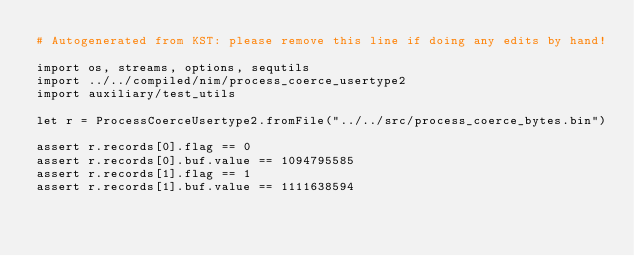<code> <loc_0><loc_0><loc_500><loc_500><_Nim_># Autogenerated from KST: please remove this line if doing any edits by hand!

import os, streams, options, sequtils
import ../../compiled/nim/process_coerce_usertype2
import auxiliary/test_utils

let r = ProcessCoerceUsertype2.fromFile("../../src/process_coerce_bytes.bin")

assert r.records[0].flag == 0
assert r.records[0].buf.value == 1094795585
assert r.records[1].flag == 1
assert r.records[1].buf.value == 1111638594
</code> 